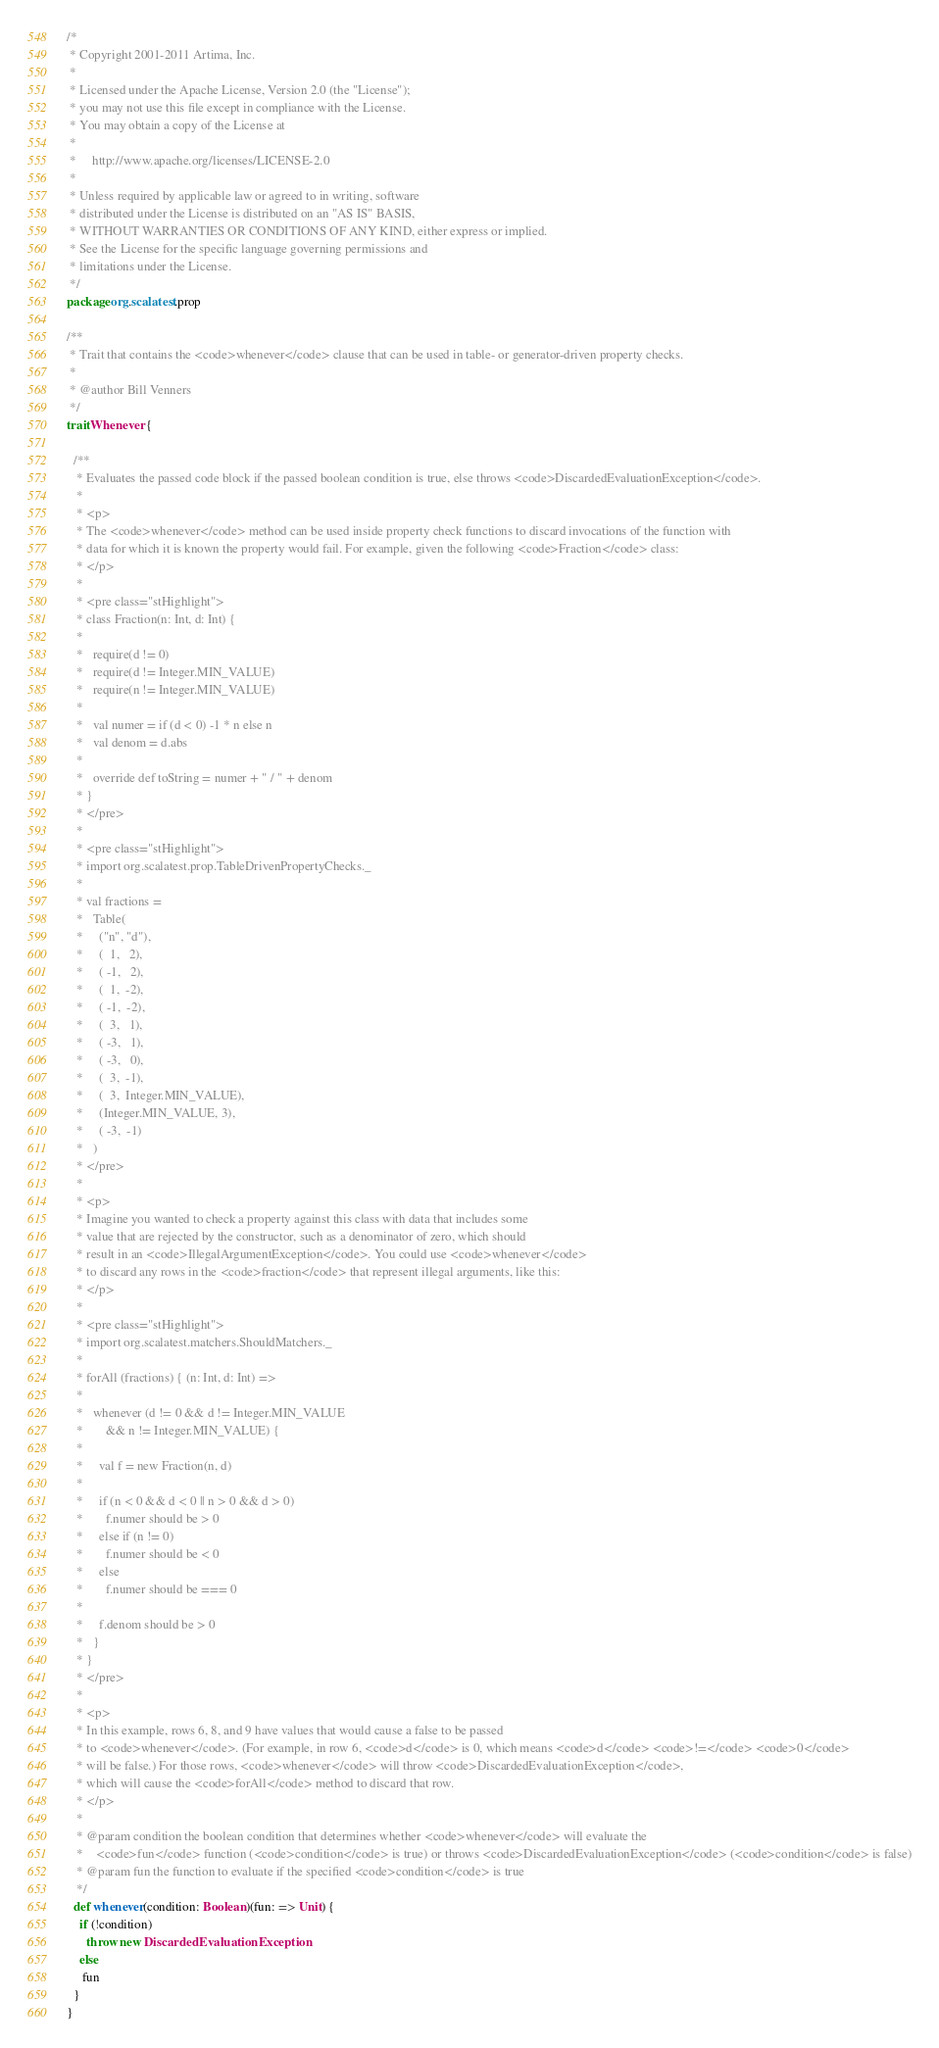<code> <loc_0><loc_0><loc_500><loc_500><_Scala_>/*
 * Copyright 2001-2011 Artima, Inc.
 *
 * Licensed under the Apache License, Version 2.0 (the "License");
 * you may not use this file except in compliance with the License.
 * You may obtain a copy of the License at
 *
 *     http://www.apache.org/licenses/LICENSE-2.0
 *
 * Unless required by applicable law or agreed to in writing, software
 * distributed under the License is distributed on an "AS IS" BASIS,
 * WITHOUT WARRANTIES OR CONDITIONS OF ANY KIND, either express or implied.
 * See the License for the specific language governing permissions and
 * limitations under the License.
 */
package org.scalatest.prop

/**
 * Trait that contains the <code>whenever</code> clause that can be used in table- or generator-driven property checks.
 *
 * @author Bill Venners
 */
trait Whenever {

  /**
   * Evaluates the passed code block if the passed boolean condition is true, else throws <code>DiscardedEvaluationException</code>.
   *
   * <p>
   * The <code>whenever</code> method can be used inside property check functions to discard invocations of the function with
   * data for which it is known the property would fail. For example, given the following <code>Fraction</code> class:
   * </p>
   *
   * <pre class="stHighlight">
   * class Fraction(n: Int, d: Int) {
   *
   *   require(d != 0)
   *   require(d != Integer.MIN_VALUE)
   *   require(n != Integer.MIN_VALUE)
   *
   *   val numer = if (d < 0) -1 * n else n
   *   val denom = d.abs
   *
   *   override def toString = numer + " / " + denom
   * }
   * </pre>
   *
   * <pre class="stHighlight">
   * import org.scalatest.prop.TableDrivenPropertyChecks._
   *
   * val fractions =
   *   Table(
   *     ("n", "d"),
   *     (  1,   2),
   *     ( -1,   2),
   *     (  1,  -2),
   *     ( -1,  -2),
   *     (  3,   1),
   *     ( -3,   1),
   *     ( -3,   0),
   *     (  3,  -1),
   *     (  3,  Integer.MIN_VALUE),
   *     (Integer.MIN_VALUE, 3),
   *     ( -3,  -1)
   *   )
   * </pre>
   *
   * <p>
   * Imagine you wanted to check a property against this class with data that includes some
   * value that are rejected by the constructor, such as a denominator of zero, which should
   * result in an <code>IllegalArgumentException</code>. You could use <code>whenever</code>
   * to discard any rows in the <code>fraction</code> that represent illegal arguments, like this:
   * </p>
   *
   * <pre class="stHighlight">
   * import org.scalatest.matchers.ShouldMatchers._
   *
   * forAll (fractions) { (n: Int, d: Int) =>
   *
   *   whenever (d != 0 && d != Integer.MIN_VALUE
   *       && n != Integer.MIN_VALUE) {
   *
   *     val f = new Fraction(n, d)
   *
   *     if (n < 0 && d < 0 || n > 0 && d > 0)
   *       f.numer should be > 0
   *     else if (n != 0)
   *       f.numer should be < 0
   *     else
   *       f.numer should be === 0
   *
   *     f.denom should be > 0
   *   }
   * }
   * </pre>
   *
   * <p>
   * In this example, rows 6, 8, and 9 have values that would cause a false to be passed
   * to <code>whenever</code>. (For example, in row 6, <code>d</code> is 0, which means <code>d</code> <code>!=</code> <code>0</code>
   * will be false.) For those rows, <code>whenever</code> will throw <code>DiscardedEvaluationException</code>,
   * which will cause the <code>forAll</code> method to discard that row.
   * </p>
   *
   * @param condition the boolean condition that determines whether <code>whenever</code> will evaluate the
   *    <code>fun</code> function (<code>condition</code> is true) or throws <code>DiscardedEvaluationException</code> (<code>condition</code> is false)
   * @param fun the function to evaluate if the specified <code>condition</code> is true
   */
  def whenever(condition: Boolean)(fun: => Unit) {
    if (!condition)
      throw new DiscardedEvaluationException
    else
     fun
  }
}
</code> 